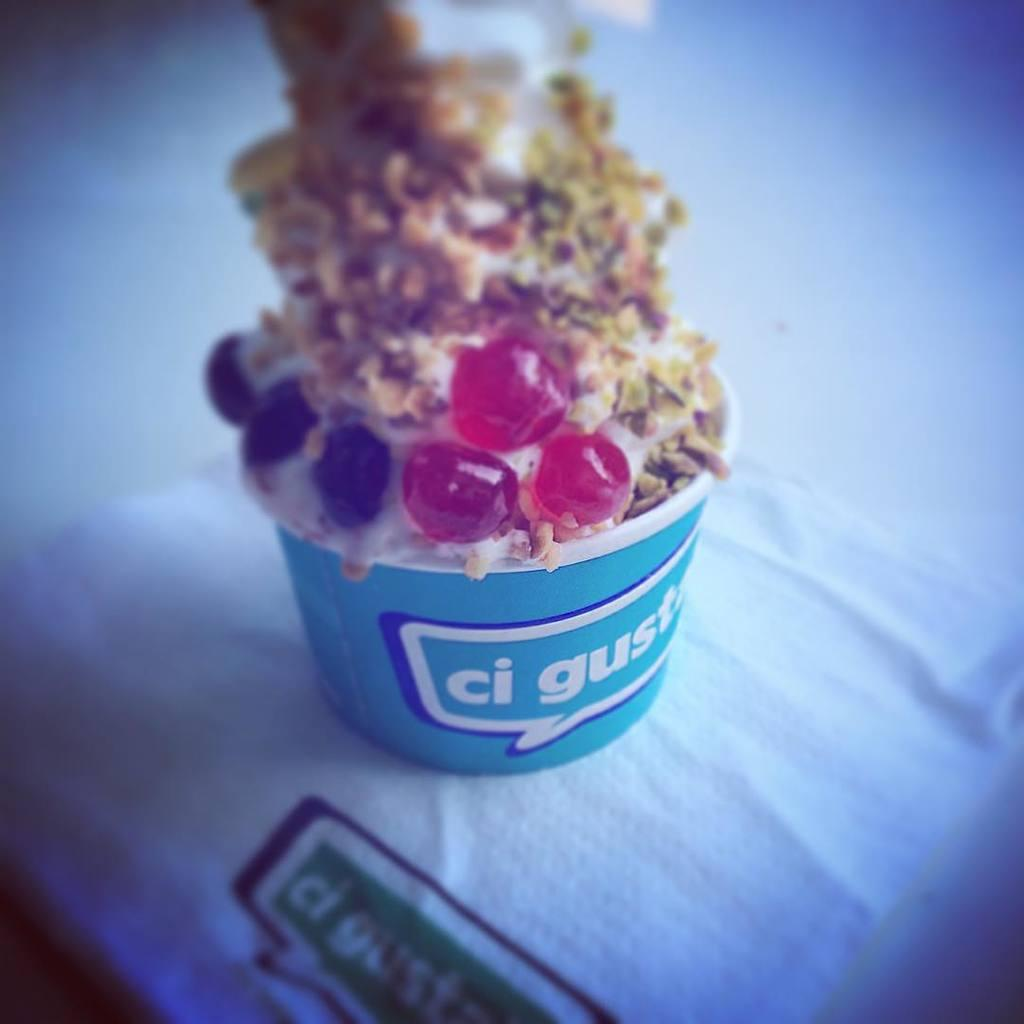What is the main subject of the image? The main subject of the image is an ice-cream. Can you describe the surface on which the ice-cream is placed? The ice-cream is on a white color surface. How many clovers are growing on the ice-cream in the image? There are no clovers present on the ice-cream in the image. What type of property is the ice-cream located on in the image? The image does not provide information about the property on which the ice-cream is located. 